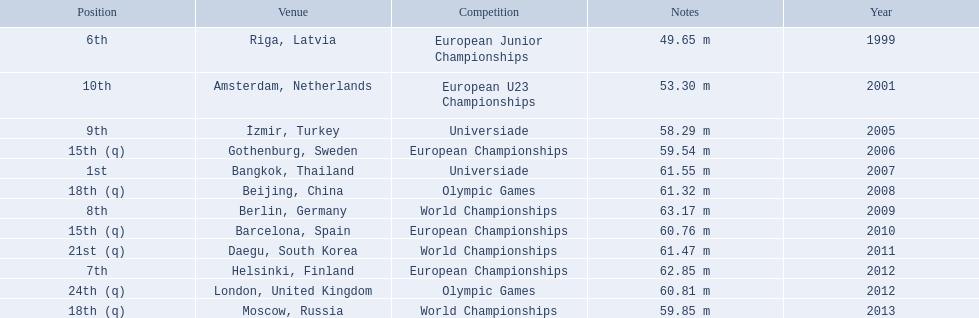What are the years that gerhard mayer participated? 1999, 2001, 2005, 2006, 2007, 2008, 2009, 2010, 2011, 2012, 2012, 2013. Which years were earlier than 2007? 1999, 2001, 2005, 2006. What was the best placing for these years? 6th. 